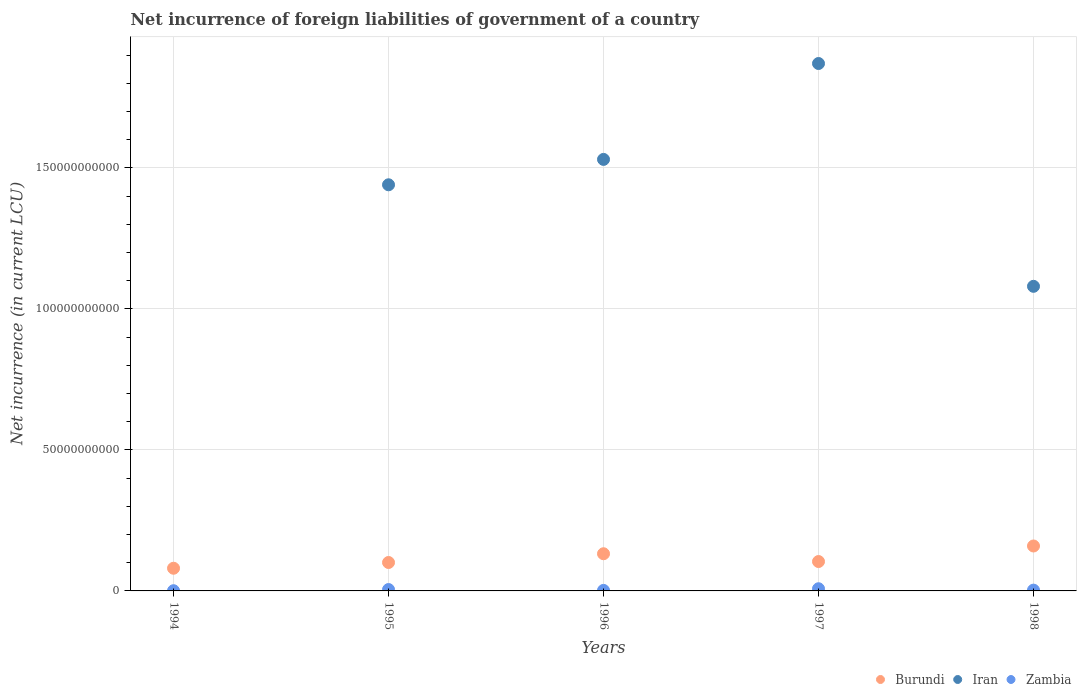What is the net incurrence of foreign liabilities in Iran in 1996?
Ensure brevity in your answer.  1.53e+11. Across all years, what is the maximum net incurrence of foreign liabilities in Burundi?
Give a very brief answer. 1.59e+1. What is the total net incurrence of foreign liabilities in Zambia in the graph?
Your answer should be very brief. 1.80e+09. What is the difference between the net incurrence of foreign liabilities in Zambia in 1997 and that in 1998?
Offer a terse response. 4.92e+08. What is the difference between the net incurrence of foreign liabilities in Burundi in 1994 and the net incurrence of foreign liabilities in Iran in 1995?
Keep it short and to the point. -1.36e+11. What is the average net incurrence of foreign liabilities in Burundi per year?
Offer a very short reply. 1.15e+1. In the year 1998, what is the difference between the net incurrence of foreign liabilities in Burundi and net incurrence of foreign liabilities in Iran?
Make the answer very short. -9.21e+1. In how many years, is the net incurrence of foreign liabilities in Burundi greater than 60000000000 LCU?
Give a very brief answer. 0. What is the ratio of the net incurrence of foreign liabilities in Burundi in 1997 to that in 1998?
Provide a short and direct response. 0.65. What is the difference between the highest and the second highest net incurrence of foreign liabilities in Zambia?
Your answer should be very brief. 2.84e+08. What is the difference between the highest and the lowest net incurrence of foreign liabilities in Burundi?
Provide a short and direct response. 7.89e+09. In how many years, is the net incurrence of foreign liabilities in Zambia greater than the average net incurrence of foreign liabilities in Zambia taken over all years?
Offer a very short reply. 2. Is the sum of the net incurrence of foreign liabilities in Iran in 1995 and 1996 greater than the maximum net incurrence of foreign liabilities in Burundi across all years?
Offer a very short reply. Yes. How many dotlines are there?
Offer a terse response. 3. Are the values on the major ticks of Y-axis written in scientific E-notation?
Make the answer very short. No. Where does the legend appear in the graph?
Keep it short and to the point. Bottom right. How many legend labels are there?
Ensure brevity in your answer.  3. What is the title of the graph?
Provide a short and direct response. Net incurrence of foreign liabilities of government of a country. What is the label or title of the Y-axis?
Your answer should be compact. Net incurrence (in current LCU). What is the Net incurrence (in current LCU) of Burundi in 1994?
Keep it short and to the point. 8.04e+09. What is the Net incurrence (in current LCU) in Iran in 1994?
Provide a short and direct response. 0. What is the Net incurrence (in current LCU) in Zambia in 1994?
Your response must be concise. 7.39e+07. What is the Net incurrence (in current LCU) in Burundi in 1995?
Your response must be concise. 1.01e+1. What is the Net incurrence (in current LCU) of Iran in 1995?
Provide a short and direct response. 1.44e+11. What is the Net incurrence (in current LCU) of Zambia in 1995?
Your answer should be very brief. 4.88e+08. What is the Net incurrence (in current LCU) of Burundi in 1996?
Your response must be concise. 1.32e+1. What is the Net incurrence (in current LCU) in Iran in 1996?
Your answer should be compact. 1.53e+11. What is the Net incurrence (in current LCU) of Zambia in 1996?
Your answer should be compact. 1.87e+08. What is the Net incurrence (in current LCU) of Burundi in 1997?
Keep it short and to the point. 1.04e+1. What is the Net incurrence (in current LCU) of Iran in 1997?
Offer a terse response. 1.87e+11. What is the Net incurrence (in current LCU) in Zambia in 1997?
Make the answer very short. 7.72e+08. What is the Net incurrence (in current LCU) in Burundi in 1998?
Ensure brevity in your answer.  1.59e+1. What is the Net incurrence (in current LCU) of Iran in 1998?
Keep it short and to the point. 1.08e+11. What is the Net incurrence (in current LCU) in Zambia in 1998?
Make the answer very short. 2.80e+08. Across all years, what is the maximum Net incurrence (in current LCU) in Burundi?
Make the answer very short. 1.59e+1. Across all years, what is the maximum Net incurrence (in current LCU) in Iran?
Provide a short and direct response. 1.87e+11. Across all years, what is the maximum Net incurrence (in current LCU) in Zambia?
Your response must be concise. 7.72e+08. Across all years, what is the minimum Net incurrence (in current LCU) of Burundi?
Keep it short and to the point. 8.04e+09. Across all years, what is the minimum Net incurrence (in current LCU) of Zambia?
Offer a very short reply. 7.39e+07. What is the total Net incurrence (in current LCU) in Burundi in the graph?
Provide a short and direct response. 5.77e+1. What is the total Net incurrence (in current LCU) in Iran in the graph?
Offer a very short reply. 5.92e+11. What is the total Net incurrence (in current LCU) in Zambia in the graph?
Your answer should be compact. 1.80e+09. What is the difference between the Net incurrence (in current LCU) in Burundi in 1994 and that in 1995?
Your response must be concise. -2.04e+09. What is the difference between the Net incurrence (in current LCU) in Zambia in 1994 and that in 1995?
Ensure brevity in your answer.  -4.14e+08. What is the difference between the Net incurrence (in current LCU) of Burundi in 1994 and that in 1996?
Your answer should be very brief. -5.14e+09. What is the difference between the Net incurrence (in current LCU) of Zambia in 1994 and that in 1996?
Ensure brevity in your answer.  -1.14e+08. What is the difference between the Net incurrence (in current LCU) of Burundi in 1994 and that in 1997?
Offer a very short reply. -2.38e+09. What is the difference between the Net incurrence (in current LCU) of Zambia in 1994 and that in 1997?
Your answer should be compact. -6.98e+08. What is the difference between the Net incurrence (in current LCU) in Burundi in 1994 and that in 1998?
Provide a short and direct response. -7.89e+09. What is the difference between the Net incurrence (in current LCU) of Zambia in 1994 and that in 1998?
Give a very brief answer. -2.06e+08. What is the difference between the Net incurrence (in current LCU) of Burundi in 1995 and that in 1996?
Provide a succinct answer. -3.10e+09. What is the difference between the Net incurrence (in current LCU) of Iran in 1995 and that in 1996?
Your answer should be compact. -9.00e+09. What is the difference between the Net incurrence (in current LCU) in Zambia in 1995 and that in 1996?
Provide a succinct answer. 3.01e+08. What is the difference between the Net incurrence (in current LCU) of Burundi in 1995 and that in 1997?
Keep it short and to the point. -3.41e+08. What is the difference between the Net incurrence (in current LCU) in Iran in 1995 and that in 1997?
Your answer should be compact. -4.30e+1. What is the difference between the Net incurrence (in current LCU) in Zambia in 1995 and that in 1997?
Your response must be concise. -2.84e+08. What is the difference between the Net incurrence (in current LCU) in Burundi in 1995 and that in 1998?
Provide a short and direct response. -5.85e+09. What is the difference between the Net incurrence (in current LCU) in Iran in 1995 and that in 1998?
Provide a short and direct response. 3.60e+1. What is the difference between the Net incurrence (in current LCU) of Zambia in 1995 and that in 1998?
Your response must be concise. 2.08e+08. What is the difference between the Net incurrence (in current LCU) in Burundi in 1996 and that in 1997?
Make the answer very short. 2.76e+09. What is the difference between the Net incurrence (in current LCU) of Iran in 1996 and that in 1997?
Offer a terse response. -3.40e+1. What is the difference between the Net incurrence (in current LCU) in Zambia in 1996 and that in 1997?
Offer a very short reply. -5.85e+08. What is the difference between the Net incurrence (in current LCU) of Burundi in 1996 and that in 1998?
Your response must be concise. -2.75e+09. What is the difference between the Net incurrence (in current LCU) in Iran in 1996 and that in 1998?
Your response must be concise. 4.50e+1. What is the difference between the Net incurrence (in current LCU) in Zambia in 1996 and that in 1998?
Make the answer very short. -9.28e+07. What is the difference between the Net incurrence (in current LCU) of Burundi in 1997 and that in 1998?
Ensure brevity in your answer.  -5.51e+09. What is the difference between the Net incurrence (in current LCU) in Iran in 1997 and that in 1998?
Your answer should be very brief. 7.90e+1. What is the difference between the Net incurrence (in current LCU) of Zambia in 1997 and that in 1998?
Make the answer very short. 4.92e+08. What is the difference between the Net incurrence (in current LCU) of Burundi in 1994 and the Net incurrence (in current LCU) of Iran in 1995?
Offer a very short reply. -1.36e+11. What is the difference between the Net incurrence (in current LCU) in Burundi in 1994 and the Net incurrence (in current LCU) in Zambia in 1995?
Your answer should be compact. 7.55e+09. What is the difference between the Net incurrence (in current LCU) of Burundi in 1994 and the Net incurrence (in current LCU) of Iran in 1996?
Offer a terse response. -1.45e+11. What is the difference between the Net incurrence (in current LCU) of Burundi in 1994 and the Net incurrence (in current LCU) of Zambia in 1996?
Make the answer very short. 7.85e+09. What is the difference between the Net incurrence (in current LCU) in Burundi in 1994 and the Net incurrence (in current LCU) in Iran in 1997?
Provide a short and direct response. -1.79e+11. What is the difference between the Net incurrence (in current LCU) in Burundi in 1994 and the Net incurrence (in current LCU) in Zambia in 1997?
Give a very brief answer. 7.27e+09. What is the difference between the Net incurrence (in current LCU) of Burundi in 1994 and the Net incurrence (in current LCU) of Iran in 1998?
Your response must be concise. -1.00e+11. What is the difference between the Net incurrence (in current LCU) of Burundi in 1994 and the Net incurrence (in current LCU) of Zambia in 1998?
Give a very brief answer. 7.76e+09. What is the difference between the Net incurrence (in current LCU) of Burundi in 1995 and the Net incurrence (in current LCU) of Iran in 1996?
Make the answer very short. -1.43e+11. What is the difference between the Net incurrence (in current LCU) of Burundi in 1995 and the Net incurrence (in current LCU) of Zambia in 1996?
Provide a succinct answer. 9.89e+09. What is the difference between the Net incurrence (in current LCU) in Iran in 1995 and the Net incurrence (in current LCU) in Zambia in 1996?
Your response must be concise. 1.44e+11. What is the difference between the Net incurrence (in current LCU) of Burundi in 1995 and the Net incurrence (in current LCU) of Iran in 1997?
Provide a succinct answer. -1.77e+11. What is the difference between the Net incurrence (in current LCU) of Burundi in 1995 and the Net incurrence (in current LCU) of Zambia in 1997?
Provide a short and direct response. 9.31e+09. What is the difference between the Net incurrence (in current LCU) of Iran in 1995 and the Net incurrence (in current LCU) of Zambia in 1997?
Provide a succinct answer. 1.43e+11. What is the difference between the Net incurrence (in current LCU) of Burundi in 1995 and the Net incurrence (in current LCU) of Iran in 1998?
Your response must be concise. -9.79e+1. What is the difference between the Net incurrence (in current LCU) in Burundi in 1995 and the Net incurrence (in current LCU) in Zambia in 1998?
Keep it short and to the point. 9.80e+09. What is the difference between the Net incurrence (in current LCU) of Iran in 1995 and the Net incurrence (in current LCU) of Zambia in 1998?
Provide a short and direct response. 1.44e+11. What is the difference between the Net incurrence (in current LCU) of Burundi in 1996 and the Net incurrence (in current LCU) of Iran in 1997?
Give a very brief answer. -1.74e+11. What is the difference between the Net incurrence (in current LCU) of Burundi in 1996 and the Net incurrence (in current LCU) of Zambia in 1997?
Your answer should be very brief. 1.24e+1. What is the difference between the Net incurrence (in current LCU) in Iran in 1996 and the Net incurrence (in current LCU) in Zambia in 1997?
Your response must be concise. 1.52e+11. What is the difference between the Net incurrence (in current LCU) in Burundi in 1996 and the Net incurrence (in current LCU) in Iran in 1998?
Ensure brevity in your answer.  -9.48e+1. What is the difference between the Net incurrence (in current LCU) of Burundi in 1996 and the Net incurrence (in current LCU) of Zambia in 1998?
Your answer should be compact. 1.29e+1. What is the difference between the Net incurrence (in current LCU) of Iran in 1996 and the Net incurrence (in current LCU) of Zambia in 1998?
Provide a short and direct response. 1.53e+11. What is the difference between the Net incurrence (in current LCU) in Burundi in 1997 and the Net incurrence (in current LCU) in Iran in 1998?
Ensure brevity in your answer.  -9.76e+1. What is the difference between the Net incurrence (in current LCU) of Burundi in 1997 and the Net incurrence (in current LCU) of Zambia in 1998?
Offer a very short reply. 1.01e+1. What is the difference between the Net incurrence (in current LCU) in Iran in 1997 and the Net incurrence (in current LCU) in Zambia in 1998?
Your response must be concise. 1.87e+11. What is the average Net incurrence (in current LCU) in Burundi per year?
Your answer should be compact. 1.15e+1. What is the average Net incurrence (in current LCU) in Iran per year?
Make the answer very short. 1.18e+11. What is the average Net incurrence (in current LCU) of Zambia per year?
Your answer should be very brief. 3.60e+08. In the year 1994, what is the difference between the Net incurrence (in current LCU) of Burundi and Net incurrence (in current LCU) of Zambia?
Keep it short and to the point. 7.97e+09. In the year 1995, what is the difference between the Net incurrence (in current LCU) of Burundi and Net incurrence (in current LCU) of Iran?
Offer a terse response. -1.34e+11. In the year 1995, what is the difference between the Net incurrence (in current LCU) of Burundi and Net incurrence (in current LCU) of Zambia?
Provide a short and direct response. 9.59e+09. In the year 1995, what is the difference between the Net incurrence (in current LCU) in Iran and Net incurrence (in current LCU) in Zambia?
Offer a very short reply. 1.44e+11. In the year 1996, what is the difference between the Net incurrence (in current LCU) in Burundi and Net incurrence (in current LCU) in Iran?
Provide a succinct answer. -1.40e+11. In the year 1996, what is the difference between the Net incurrence (in current LCU) of Burundi and Net incurrence (in current LCU) of Zambia?
Your response must be concise. 1.30e+1. In the year 1996, what is the difference between the Net incurrence (in current LCU) of Iran and Net incurrence (in current LCU) of Zambia?
Keep it short and to the point. 1.53e+11. In the year 1997, what is the difference between the Net incurrence (in current LCU) of Burundi and Net incurrence (in current LCU) of Iran?
Ensure brevity in your answer.  -1.77e+11. In the year 1997, what is the difference between the Net incurrence (in current LCU) of Burundi and Net incurrence (in current LCU) of Zambia?
Keep it short and to the point. 9.65e+09. In the year 1997, what is the difference between the Net incurrence (in current LCU) in Iran and Net incurrence (in current LCU) in Zambia?
Provide a short and direct response. 1.86e+11. In the year 1998, what is the difference between the Net incurrence (in current LCU) in Burundi and Net incurrence (in current LCU) in Iran?
Your response must be concise. -9.21e+1. In the year 1998, what is the difference between the Net incurrence (in current LCU) in Burundi and Net incurrence (in current LCU) in Zambia?
Keep it short and to the point. 1.57e+1. In the year 1998, what is the difference between the Net incurrence (in current LCU) of Iran and Net incurrence (in current LCU) of Zambia?
Offer a very short reply. 1.08e+11. What is the ratio of the Net incurrence (in current LCU) in Burundi in 1994 to that in 1995?
Make the answer very short. 0.8. What is the ratio of the Net incurrence (in current LCU) of Zambia in 1994 to that in 1995?
Keep it short and to the point. 0.15. What is the ratio of the Net incurrence (in current LCU) of Burundi in 1994 to that in 1996?
Your response must be concise. 0.61. What is the ratio of the Net incurrence (in current LCU) in Zambia in 1994 to that in 1996?
Make the answer very short. 0.39. What is the ratio of the Net incurrence (in current LCU) in Burundi in 1994 to that in 1997?
Ensure brevity in your answer.  0.77. What is the ratio of the Net incurrence (in current LCU) of Zambia in 1994 to that in 1997?
Make the answer very short. 0.1. What is the ratio of the Net incurrence (in current LCU) in Burundi in 1994 to that in 1998?
Make the answer very short. 0.5. What is the ratio of the Net incurrence (in current LCU) of Zambia in 1994 to that in 1998?
Provide a succinct answer. 0.26. What is the ratio of the Net incurrence (in current LCU) in Burundi in 1995 to that in 1996?
Give a very brief answer. 0.76. What is the ratio of the Net incurrence (in current LCU) of Iran in 1995 to that in 1996?
Keep it short and to the point. 0.94. What is the ratio of the Net incurrence (in current LCU) of Zambia in 1995 to that in 1996?
Your response must be concise. 2.61. What is the ratio of the Net incurrence (in current LCU) in Burundi in 1995 to that in 1997?
Make the answer very short. 0.97. What is the ratio of the Net incurrence (in current LCU) of Iran in 1995 to that in 1997?
Offer a terse response. 0.77. What is the ratio of the Net incurrence (in current LCU) in Zambia in 1995 to that in 1997?
Keep it short and to the point. 0.63. What is the ratio of the Net incurrence (in current LCU) of Burundi in 1995 to that in 1998?
Make the answer very short. 0.63. What is the ratio of the Net incurrence (in current LCU) of Zambia in 1995 to that in 1998?
Provide a succinct answer. 1.74. What is the ratio of the Net incurrence (in current LCU) of Burundi in 1996 to that in 1997?
Your response must be concise. 1.26. What is the ratio of the Net incurrence (in current LCU) in Iran in 1996 to that in 1997?
Your response must be concise. 0.82. What is the ratio of the Net incurrence (in current LCU) in Zambia in 1996 to that in 1997?
Make the answer very short. 0.24. What is the ratio of the Net incurrence (in current LCU) in Burundi in 1996 to that in 1998?
Offer a very short reply. 0.83. What is the ratio of the Net incurrence (in current LCU) of Iran in 1996 to that in 1998?
Offer a terse response. 1.42. What is the ratio of the Net incurrence (in current LCU) in Zambia in 1996 to that in 1998?
Your answer should be very brief. 0.67. What is the ratio of the Net incurrence (in current LCU) of Burundi in 1997 to that in 1998?
Offer a very short reply. 0.65. What is the ratio of the Net incurrence (in current LCU) in Iran in 1997 to that in 1998?
Your response must be concise. 1.73. What is the ratio of the Net incurrence (in current LCU) of Zambia in 1997 to that in 1998?
Your response must be concise. 2.76. What is the difference between the highest and the second highest Net incurrence (in current LCU) in Burundi?
Ensure brevity in your answer.  2.75e+09. What is the difference between the highest and the second highest Net incurrence (in current LCU) of Iran?
Keep it short and to the point. 3.40e+1. What is the difference between the highest and the second highest Net incurrence (in current LCU) of Zambia?
Give a very brief answer. 2.84e+08. What is the difference between the highest and the lowest Net incurrence (in current LCU) of Burundi?
Make the answer very short. 7.89e+09. What is the difference between the highest and the lowest Net incurrence (in current LCU) of Iran?
Provide a succinct answer. 1.87e+11. What is the difference between the highest and the lowest Net incurrence (in current LCU) in Zambia?
Offer a terse response. 6.98e+08. 